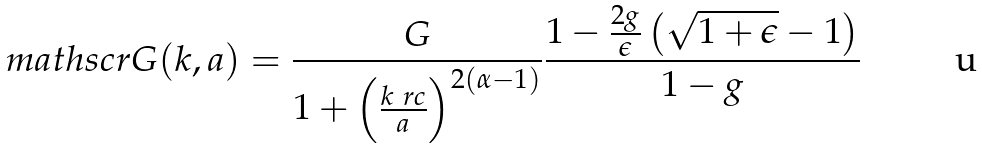<formula> <loc_0><loc_0><loc_500><loc_500>\ m a t h s c r G ( k , a ) = \frac { G } { 1 + \left ( \frac { k \ r c } { a } \right ) ^ { 2 \left ( \alpha - 1 \right ) } } \frac { 1 - \frac { 2 g } { \epsilon } \left ( \sqrt { 1 + \epsilon } - 1 \right ) } { 1 - g }</formula> 